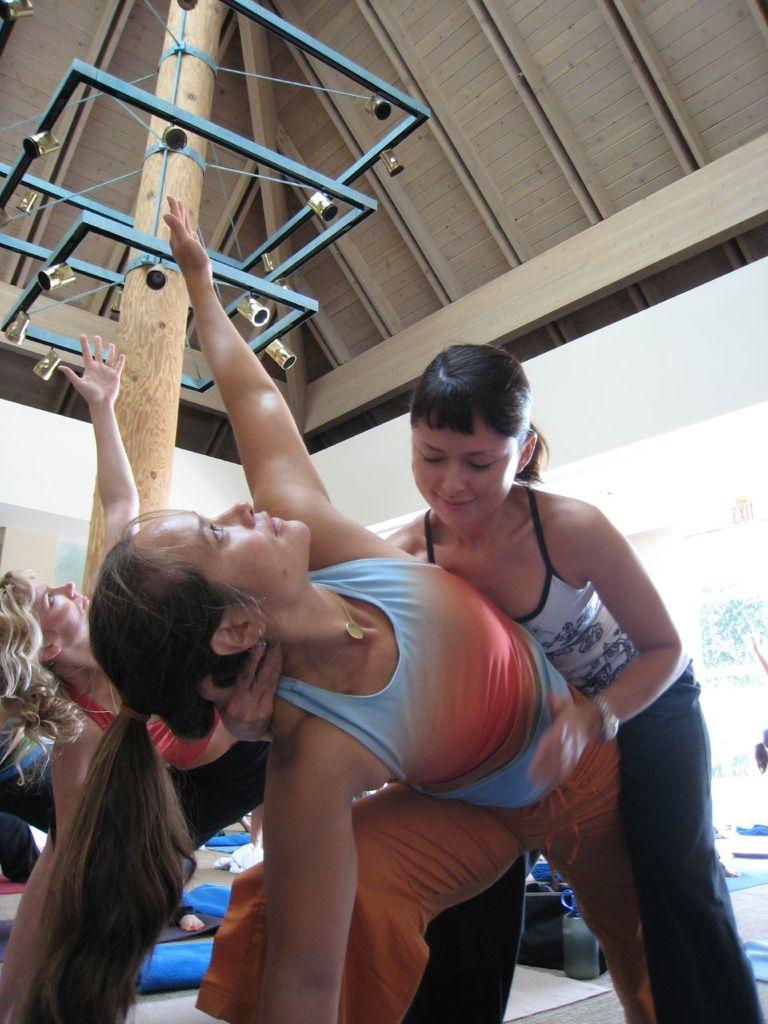What is the main subject of the image? The main subject of the image is a group of people. Where are the people located in the image? The group of people is at the bottom of the image. What can be seen in the background of the image? There is a wooden roof in the background of the image. What language are the people speaking in the image? The provided facts do not mention the language spoken by the people in the image, so it cannot be determined from the image. --- Facts: 1. There is a car in the image. 2. The car is parked on the street. 3. There are trees on both sides of the street. 4. The sky is visible in the image. Absurd Topics: parrot, dance, ocean Conversation: What is the main subject of the image? The main subject of the image is a car. Where is the car located in the image? The car is parked on the street. What can be seen on both sides of the street in the image? There are trees on both sides of the street. What is visible in the background of the image? The sky is visible in the image. Reasoning: Let's think step by step in order to produce the conversation. We start by identifying the main subject of the image, which is the car. Then, we describe the car's location, noting that it is parked on the street. Next, we mention the trees on both sides of the street, which provide context about the setting. Finally, we acknowledge the presence of the sky in the background. Absurd Question/Answer: Can you see a parrot dancing by the ocean in the image? No, there is no parrot, dancing, or ocean present in the image. 